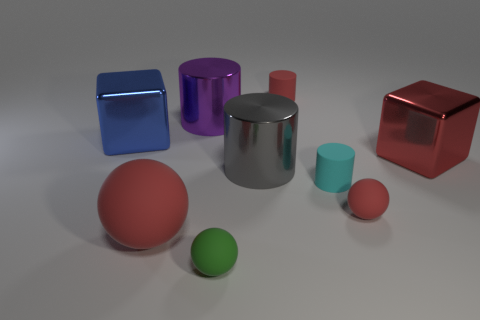The blue metal thing has what size?
Your answer should be very brief. Large. What number of other things are there of the same color as the large rubber ball?
Your response must be concise. 3. There is a large red thing in front of the large gray metallic thing; does it have the same shape as the green rubber object?
Provide a short and direct response. Yes. There is another small matte object that is the same shape as the small green rubber object; what color is it?
Your answer should be very brief. Red. Are there any other things that are the same material as the cyan cylinder?
Make the answer very short. Yes. What size is the cyan rubber object that is the same shape as the big purple shiny object?
Your answer should be compact. Small. What is the big object that is both to the right of the big red sphere and behind the large red metal object made of?
Keep it short and to the point. Metal. Is the color of the large metallic cylinder that is on the left side of the big gray metallic cylinder the same as the big sphere?
Keep it short and to the point. No. Is the color of the large sphere the same as the large shiny block that is right of the blue cube?
Provide a succinct answer. Yes. Are there any green matte balls to the left of the big sphere?
Ensure brevity in your answer.  No. 